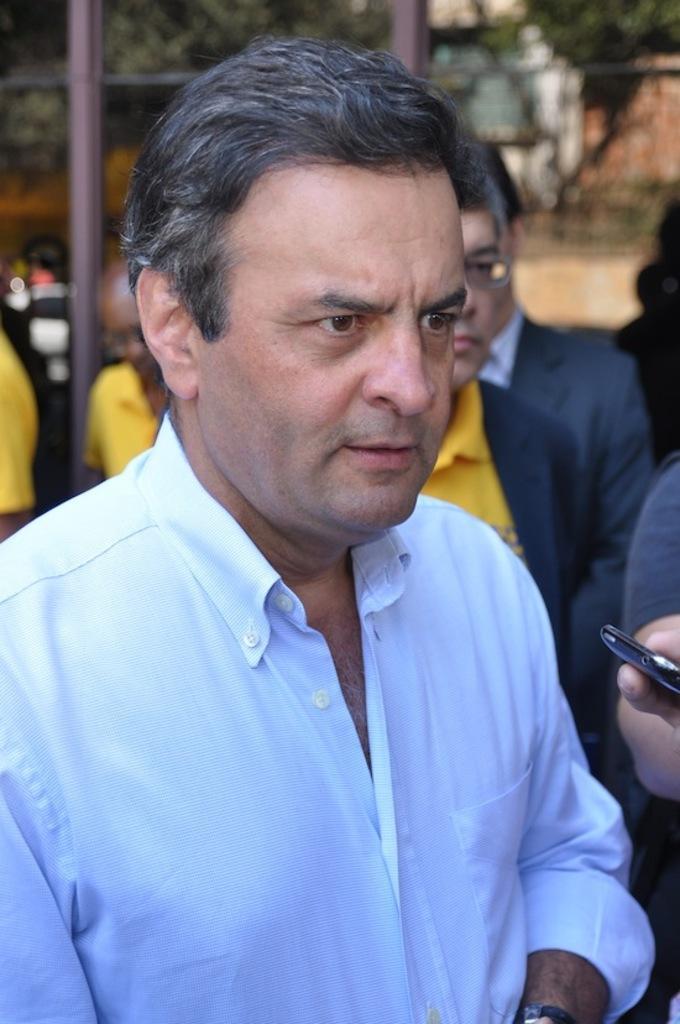Describe this image in one or two sentences. In this picture I can see few people are standing and I can see a human hand holding a mobile and I can see trees, couple of metal poles and looks like a wall on the back. 